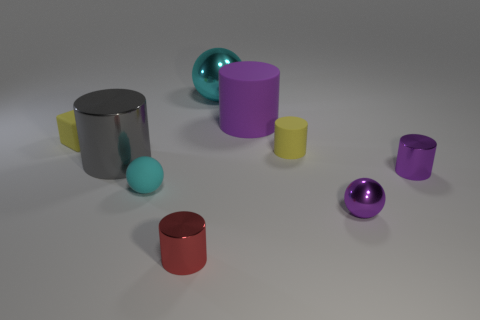Is there a small cyan rubber thing that is left of the metal ball that is behind the purple rubber object?
Your response must be concise. Yes. How many other objects are there of the same color as the tiny matte cylinder?
Make the answer very short. 1. Do the yellow rubber thing that is on the right side of the big gray metallic thing and the yellow rubber object to the left of the cyan matte object have the same size?
Keep it short and to the point. Yes. What size is the shiny ball that is in front of the tiny metal cylinder to the right of the large cyan metal object?
Your answer should be compact. Small. There is a sphere that is in front of the big cyan metallic object and left of the big purple matte cylinder; what is its material?
Keep it short and to the point. Rubber. The large metallic ball is what color?
Provide a short and direct response. Cyan. There is a purple object that is behind the small purple shiny cylinder; what shape is it?
Provide a succinct answer. Cylinder. Are there any tiny matte objects that are left of the metal ball behind the metal cylinder to the left of the tiny cyan ball?
Provide a succinct answer. Yes. Is there a tiny matte thing?
Offer a very short reply. Yes. Is the material of the purple cylinder behind the small yellow matte cube the same as the small yellow object to the left of the big metallic cylinder?
Your answer should be very brief. Yes. 